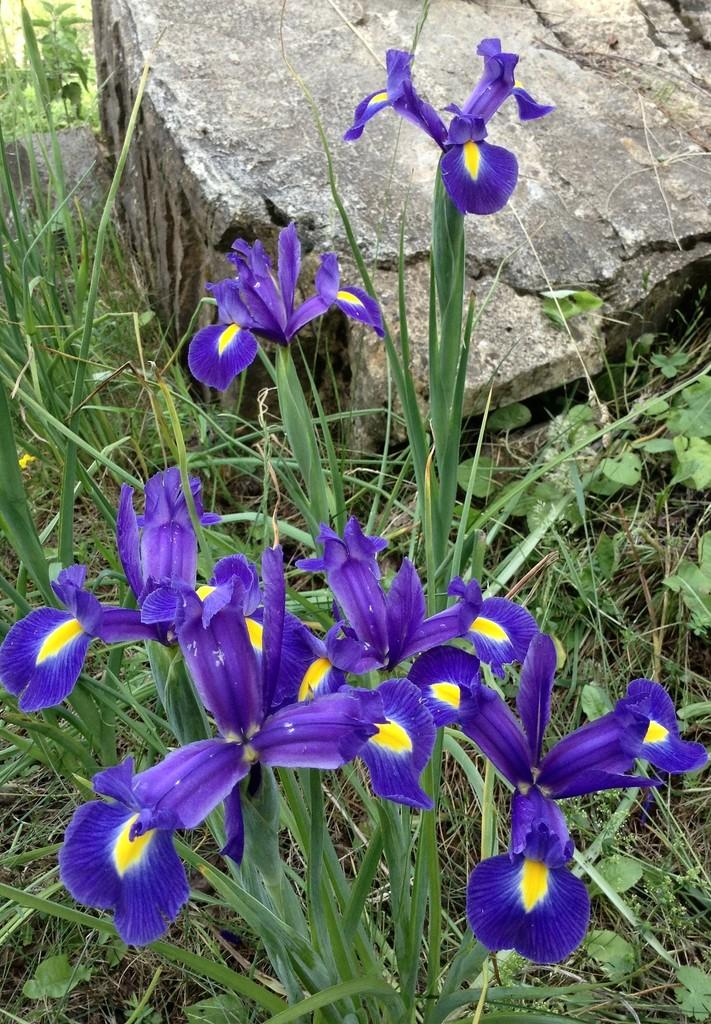What is located in the foreground of the image? There are flowers in the foreground of the image. What type of plants are the flowers associated with? The flowers are associated with plants. What is on the ground in the foreground of the image? There is grass on the ground in the foreground. What can be seen at the top of the image? There is a stone visible at the top of the image. What type of hydrant is present in the image? There is no hydrant present in the image. Can you confirm the existence of a basket in the image? There is no basket present in the image. 